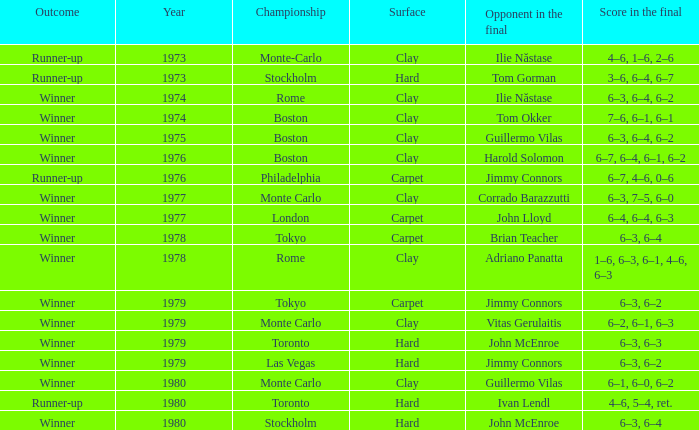Specify the clay year for boston and guillermo vilas. 1975.0. 